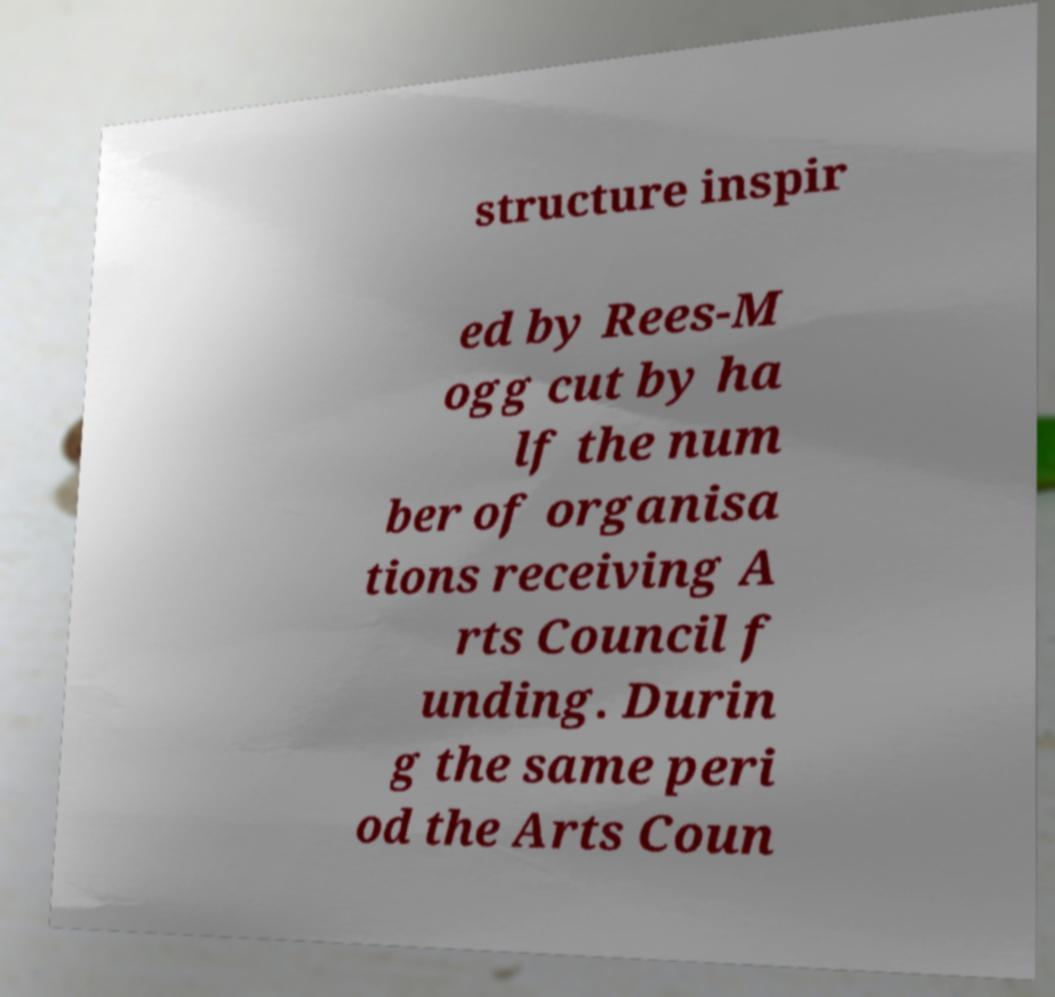Could you assist in decoding the text presented in this image and type it out clearly? structure inspir ed by Rees-M ogg cut by ha lf the num ber of organisa tions receiving A rts Council f unding. Durin g the same peri od the Arts Coun 